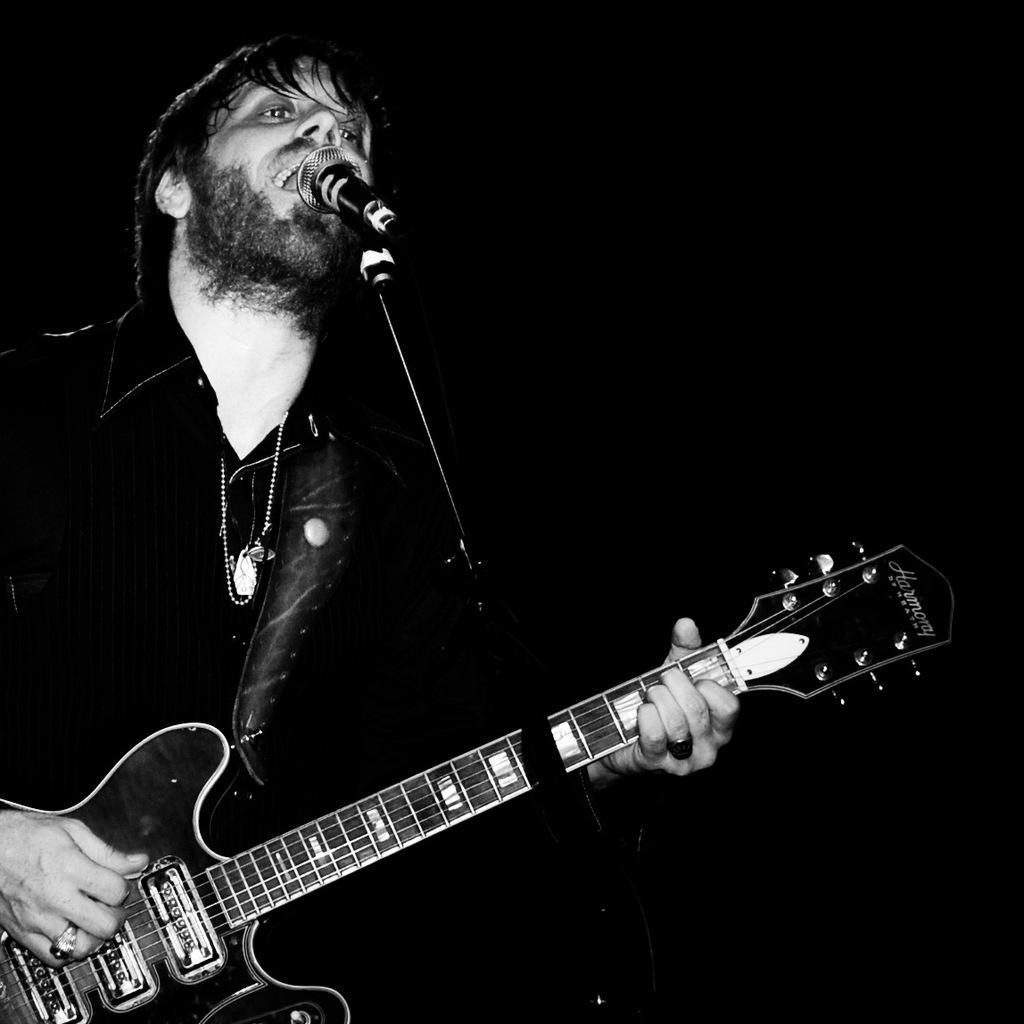Can you describe this image briefly? This picture shows a man singing in front of a mic and playing a guitar in his hands. In the background there is completely dark. 